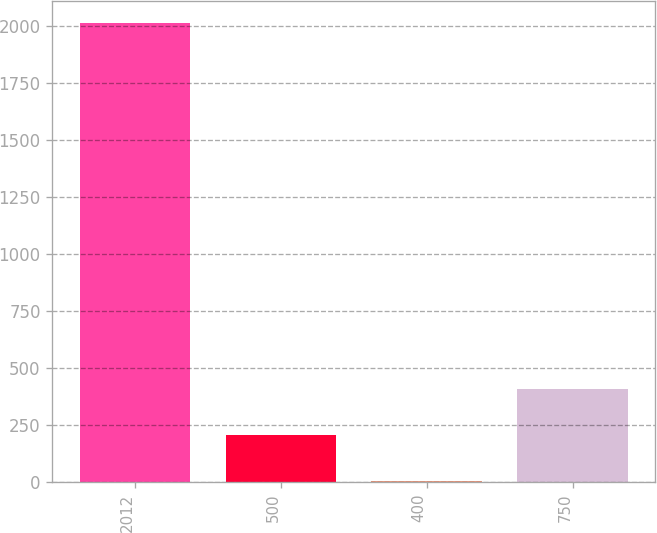Convert chart to OTSL. <chart><loc_0><loc_0><loc_500><loc_500><bar_chart><fcel>2012<fcel>500<fcel>400<fcel>750<nl><fcel>2010<fcel>205.44<fcel>4.93<fcel>405.95<nl></chart> 